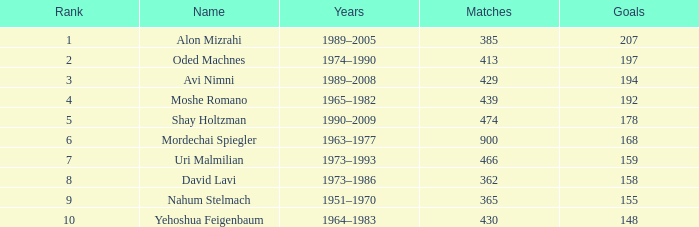What is the standing of the player with 158 goals in beyond 362 matches? 0.0. 